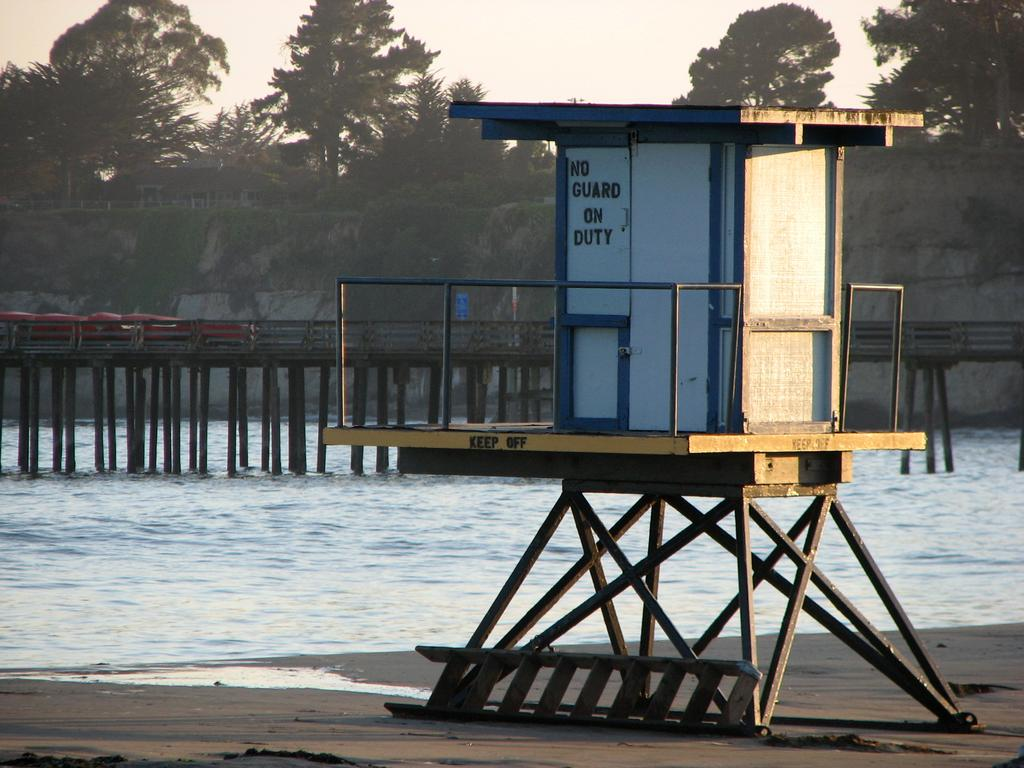What type of room is depicted in the image? There is a safeguard room in the image. What can be used to access higher areas in the image? There is a ladder in the image. What is present in the image that might be used for crossing water? There is a bridge in the image. What type of vegetation is visible in the image? There are trees in the image. What is visible in the background of the image? The sky is visible in the background of the image. What type of protest is taking place in the image? There is no protest present in the image. What type of office equipment can be seen in the image? There is no office equipment present in the image. 